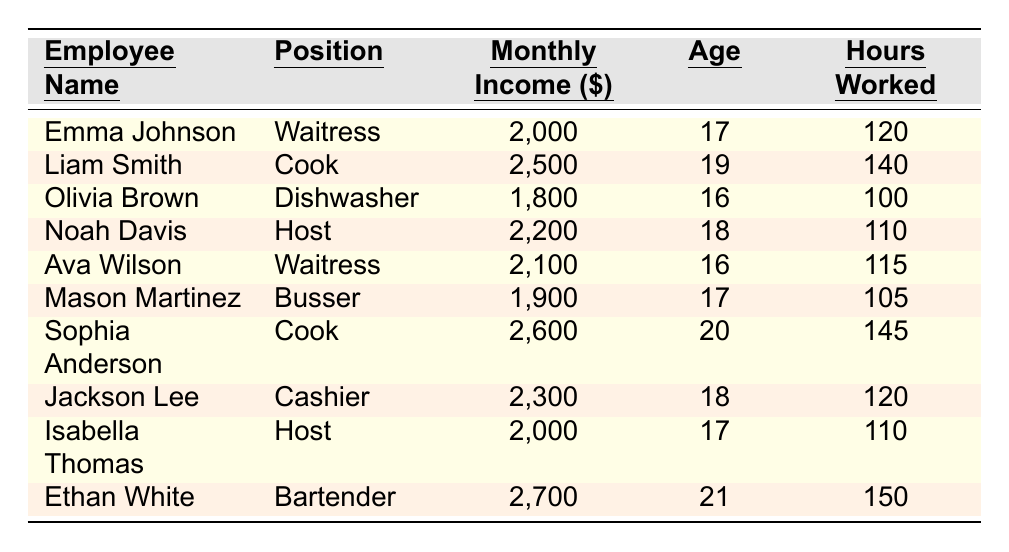What is the monthly income of Liam Smith? The table lists Liam Smith's monthly income in the "Monthly Income ($)" column, which shows it as 2,500.
Answer: 2,500 How many hours did Emma Johnson work? In the "Hours Worked" column, it specifies that Emma Johnson worked a total of 120 hours.
Answer: 120 Which employee has the highest monthly income? By comparing the values in the "Monthly Income ($)" column, Ethan White has the highest income at 2,700.
Answer: Ethan White What is the average monthly income of all employees? First, sum the monthly incomes: 2000 + 2500 + 1800 + 2200 + 2100 + 1900 + 2600 + 2300 + 2000 + 2700 = 25,100. There are 10 employees, so the average is 25,100 / 10 = 2,510.
Answer: 2,510 Is Olivia Brown older than Emma Johnson? Olivia Brown's age is listed as 16 and Emma Johnson's age is 17; therefore, Olivia is not older than Emma.
Answer: No How many employees earn more than 2,000 dollars a month? Identify those who earn more than 2,000: Liam Smith (2,500), Noah Davis (2,200), Ava Wilson (2,100), Sophia Anderson (2,600), Jackson Lee (2,300), and Ethan White (2,700). Counting these, there are 6 employees.
Answer: 6 What is the difference in monthly income between the highest and lowest earners? The highest monthly income is 2,700 (Ethan White) and the lowest is 1,800 (Olivia Brown). The difference is 2,700 - 1,800 = 900.
Answer: 900 Which employees worked more than 120 hours? Reviewing the "Hours Worked" column, employees who worked more than 120 hours are Liam Smith (140), Sophia Anderson (145), and Ethan White (150).
Answer: Liam Smith, Sophia Anderson, Ethan White What position does the second highest earner hold? The second highest earner is Sophia Anderson with a monthly income of 2,600, and her position is Cook.
Answer: Cook Are there any employees aged 17? The table shows Emma Johnson, Mason Martinez, and Isabella Thomas are all 17 years old. Thus, there are employees aged 17.
Answer: Yes What is the total monthly income of the employees under the age of 18? First, identify those under 18: Emma Johnson (2,000), Olivia Brown (1,800), Noah Davis (2,200), Ava Wilson (2,100), and Mason Martinez (1,900). Their total monthly income is 2,000 + 1,800 + 2,200 + 2,100 + 1,900 = 11,000.
Answer: 11,000 